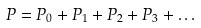Convert formula to latex. <formula><loc_0><loc_0><loc_500><loc_500>P = P _ { 0 } + P _ { 1 } + P _ { 2 } + P _ { 3 } + \dots</formula> 